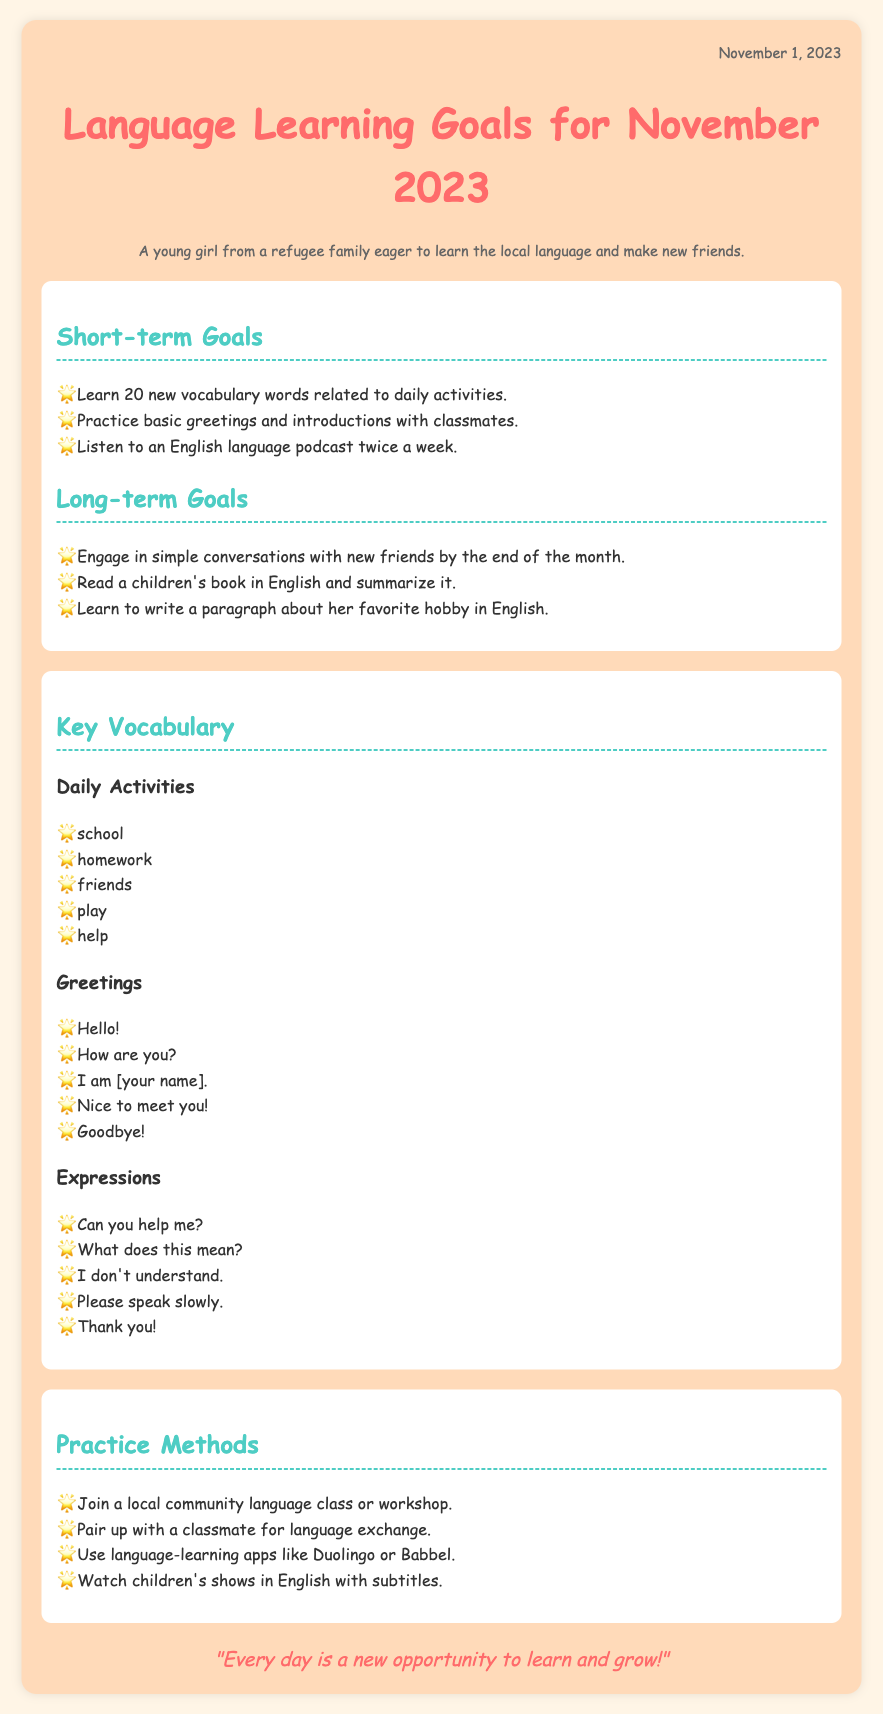What is the date of the memo? The date is mentioned at the top of the document as "November 1, 2023."
Answer: November 1, 2023 How many new vocabulary words does the memo suggest learning? The memo states that the goal is to learn 20 new vocabulary words.
Answer: 20 What is one of the basic greetings listed in the document? The document includes various greetings; one example is "Hello!"
Answer: Hello! What is one method suggested for practice? The document lists several methods; one example is "Join a local community language class or workshop."
Answer: Join a local community language class or workshop What is the theme of the quote at the bottom of the memo? The quote emphasizes positivity and taking advantage of opportunities for learning and growth.
Answer: New opportunities What is one long-term goal mentioned in the memo? One long-term goal is to "Engage in simple conversations with new friends by the end of the month."
Answer: Engage in simple conversations with new friends What type of vocabulary is highlighted in the "Daily Activities" section? The "Daily Activities" section features words related to common tasks encountered each day.
Answer: Words related to daily activities How many times a week does the memo suggest listening to a podcast? The document specifies that listening to an English language podcast should be done twice a week.
Answer: Twice a week What is the persona described in the memo? The persona is described as a "young girl from a refugee family eager to learn the local language and make new friends."
Answer: Young girl from a refugee family What type of document is this memo categorized as? This document is a set of language learning goals organized for a specific month.
Answer: Memo 